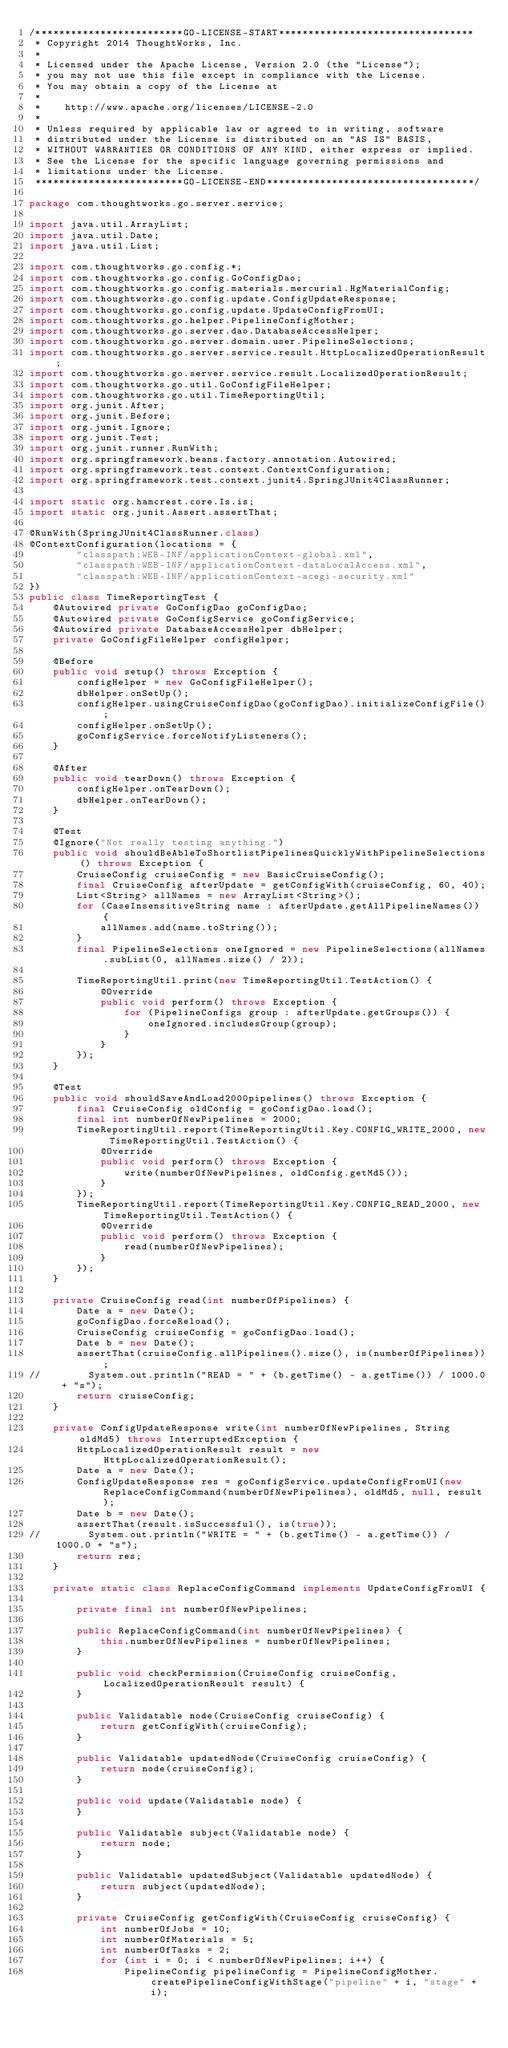Convert code to text. <code><loc_0><loc_0><loc_500><loc_500><_Java_>/*************************GO-LICENSE-START*********************************
 * Copyright 2014 ThoughtWorks, Inc.
 *
 * Licensed under the Apache License, Version 2.0 (the "License");
 * you may not use this file except in compliance with the License.
 * You may obtain a copy of the License at
 *
 *    http://www.apache.org/licenses/LICENSE-2.0
 *
 * Unless required by applicable law or agreed to in writing, software
 * distributed under the License is distributed on an "AS IS" BASIS,
 * WITHOUT WARRANTIES OR CONDITIONS OF ANY KIND, either express or implied.
 * See the License for the specific language governing permissions and
 * limitations under the License.
 *************************GO-LICENSE-END***********************************/

package com.thoughtworks.go.server.service;

import java.util.ArrayList;
import java.util.Date;
import java.util.List;

import com.thoughtworks.go.config.*;
import com.thoughtworks.go.config.GoConfigDao;
import com.thoughtworks.go.config.materials.mercurial.HgMaterialConfig;
import com.thoughtworks.go.config.update.ConfigUpdateResponse;
import com.thoughtworks.go.config.update.UpdateConfigFromUI;
import com.thoughtworks.go.helper.PipelineConfigMother;
import com.thoughtworks.go.server.dao.DatabaseAccessHelper;
import com.thoughtworks.go.server.domain.user.PipelineSelections;
import com.thoughtworks.go.server.service.result.HttpLocalizedOperationResult;
import com.thoughtworks.go.server.service.result.LocalizedOperationResult;
import com.thoughtworks.go.util.GoConfigFileHelper;
import com.thoughtworks.go.util.TimeReportingUtil;
import org.junit.After;
import org.junit.Before;
import org.junit.Ignore;
import org.junit.Test;
import org.junit.runner.RunWith;
import org.springframework.beans.factory.annotation.Autowired;
import org.springframework.test.context.ContextConfiguration;
import org.springframework.test.context.junit4.SpringJUnit4ClassRunner;

import static org.hamcrest.core.Is.is;
import static org.junit.Assert.assertThat;

@RunWith(SpringJUnit4ClassRunner.class)
@ContextConfiguration(locations = {
        "classpath:WEB-INF/applicationContext-global.xml",
        "classpath:WEB-INF/applicationContext-dataLocalAccess.xml",
        "classpath:WEB-INF/applicationContext-acegi-security.xml"
})
public class TimeReportingTest {
    @Autowired private GoConfigDao goConfigDao;
    @Autowired private GoConfigService goConfigService;
    @Autowired private DatabaseAccessHelper dbHelper;
    private GoConfigFileHelper configHelper;

    @Before
    public void setup() throws Exception {
        configHelper = new GoConfigFileHelper();
        dbHelper.onSetUp();
        configHelper.usingCruiseConfigDao(goConfigDao).initializeConfigFile();
        configHelper.onSetUp();
        goConfigService.forceNotifyListeners();
    }

    @After
    public void tearDown() throws Exception {
        configHelper.onTearDown();
        dbHelper.onTearDown();
    }
    
    @Test
    @Ignore("Not really testing anything.")
    public void shouldBeAbleToShortlistPipelinesQuicklyWithPipelineSelections() throws Exception {
        CruiseConfig cruiseConfig = new BasicCruiseConfig();
        final CruiseConfig afterUpdate = getConfigWith(cruiseConfig, 60, 40);
        List<String> allNames = new ArrayList<String>();
        for (CaseInsensitiveString name : afterUpdate.getAllPipelineNames()) {
            allNames.add(name.toString());
        }
        final PipelineSelections oneIgnored = new PipelineSelections(allNames.subList(0, allNames.size() / 2));

        TimeReportingUtil.print(new TimeReportingUtil.TestAction() {
            @Override
            public void perform() throws Exception {
                for (PipelineConfigs group : afterUpdate.getGroups()) {
                    oneIgnored.includesGroup(group);
                }
            }
        });
    }

    @Test
    public void shouldSaveAndLoad2000pipelines() throws Exception {
        final CruiseConfig oldConfig = goConfigDao.load();
        final int numberOfNewPipelines = 2000;
        TimeReportingUtil.report(TimeReportingUtil.Key.CONFIG_WRITE_2000, new TimeReportingUtil.TestAction() {
            @Override
            public void perform() throws Exception {
                write(numberOfNewPipelines, oldConfig.getMd5());
            }
        });
        TimeReportingUtil.report(TimeReportingUtil.Key.CONFIG_READ_2000, new TimeReportingUtil.TestAction() {
            @Override
            public void perform() throws Exception {
                read(numberOfNewPipelines);
            }
        });
    }

    private CruiseConfig read(int numberOfPipelines) {
        Date a = new Date();
        goConfigDao.forceReload();
        CruiseConfig cruiseConfig = goConfigDao.load();
        Date b = new Date();
        assertThat(cruiseConfig.allPipelines().size(), is(numberOfPipelines));
//        System.out.println("READ = " + (b.getTime() - a.getTime()) / 1000.0 + "s");
        return cruiseConfig;
    }

    private ConfigUpdateResponse write(int numberOfNewPipelines, String oldMd5) throws InterruptedException {
        HttpLocalizedOperationResult result = new HttpLocalizedOperationResult();
        Date a = new Date();
        ConfigUpdateResponse res = goConfigService.updateConfigFromUI(new ReplaceConfigCommand(numberOfNewPipelines), oldMd5, null, result);
        Date b = new Date();
        assertThat(result.isSuccessful(), is(true));
//        System.out.println("WRITE = " + (b.getTime() - a.getTime()) / 1000.0 + "s");
        return res;
    }

    private static class ReplaceConfigCommand implements UpdateConfigFromUI {

        private final int numberOfNewPipelines;

        public ReplaceConfigCommand(int numberOfNewPipelines) {
            this.numberOfNewPipelines = numberOfNewPipelines;
        }

        public void checkPermission(CruiseConfig cruiseConfig, LocalizedOperationResult result) {
        }

        public Validatable node(CruiseConfig cruiseConfig) {
            return getConfigWith(cruiseConfig);
        }

        public Validatable updatedNode(CruiseConfig cruiseConfig) {
            return node(cruiseConfig);
        }

        public void update(Validatable node) {
        }

        public Validatable subject(Validatable node) {
            return node;
        }

        public Validatable updatedSubject(Validatable updatedNode) {
            return subject(updatedNode);
        }

        private CruiseConfig getConfigWith(CruiseConfig cruiseConfig) {
            int numberOfJobs = 10;
            int numberOfMaterials = 5;
            int numberOfTasks = 2;
            for (int i = 0; i < numberOfNewPipelines; i++) {
                PipelineConfig pipelineConfig = PipelineConfigMother.createPipelineConfigWithStage("pipeline" + i, "stage" + i);</code> 